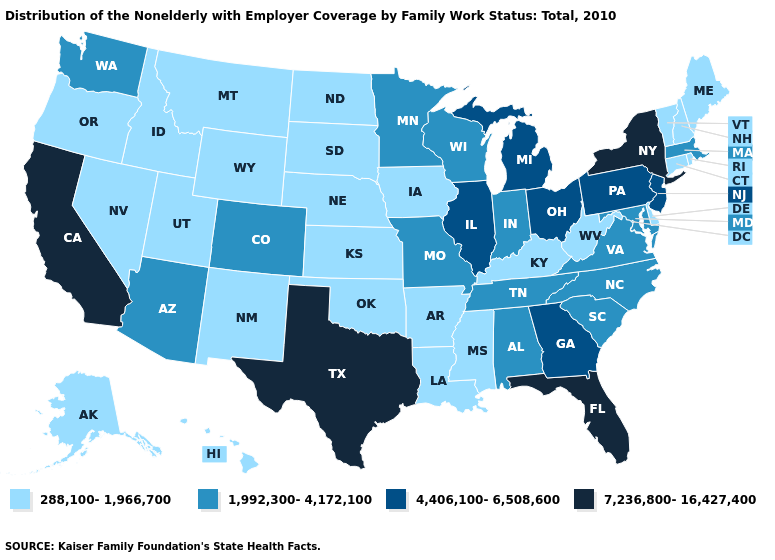Name the states that have a value in the range 288,100-1,966,700?
Answer briefly. Alaska, Arkansas, Connecticut, Delaware, Hawaii, Idaho, Iowa, Kansas, Kentucky, Louisiana, Maine, Mississippi, Montana, Nebraska, Nevada, New Hampshire, New Mexico, North Dakota, Oklahoma, Oregon, Rhode Island, South Dakota, Utah, Vermont, West Virginia, Wyoming. Which states have the highest value in the USA?
Quick response, please. California, Florida, New York, Texas. What is the lowest value in the Northeast?
Answer briefly. 288,100-1,966,700. Which states have the lowest value in the Northeast?
Concise answer only. Connecticut, Maine, New Hampshire, Rhode Island, Vermont. Does Delaware have the same value as Alaska?
Quick response, please. Yes. Is the legend a continuous bar?
Answer briefly. No. Does New Jersey have the highest value in the Northeast?
Write a very short answer. No. Does New Mexico have the highest value in the USA?
Write a very short answer. No. Is the legend a continuous bar?
Short answer required. No. Does Alabama have the highest value in the USA?
Write a very short answer. No. What is the lowest value in the South?
Keep it brief. 288,100-1,966,700. Does Texas have the highest value in the USA?
Short answer required. Yes. Does Alaska have a lower value than Virginia?
Write a very short answer. Yes. Does New York have the same value as Florida?
Concise answer only. Yes. 